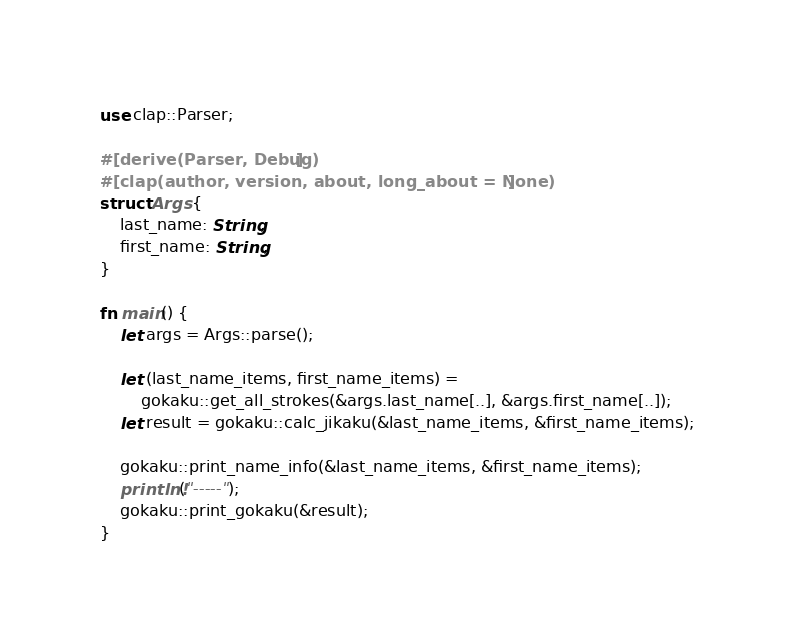<code> <loc_0><loc_0><loc_500><loc_500><_Rust_>use clap::Parser;

#[derive(Parser, Debug)]
#[clap(author, version, about, long_about = None)]
struct Args {
    last_name: String,
    first_name: String,
}

fn main() {
    let args = Args::parse();

    let (last_name_items, first_name_items) =
        gokaku::get_all_strokes(&args.last_name[..], &args.first_name[..]);
    let result = gokaku::calc_jikaku(&last_name_items, &first_name_items);

    gokaku::print_name_info(&last_name_items, &first_name_items);
    println!("-----");
    gokaku::print_gokaku(&result);
}
</code> 